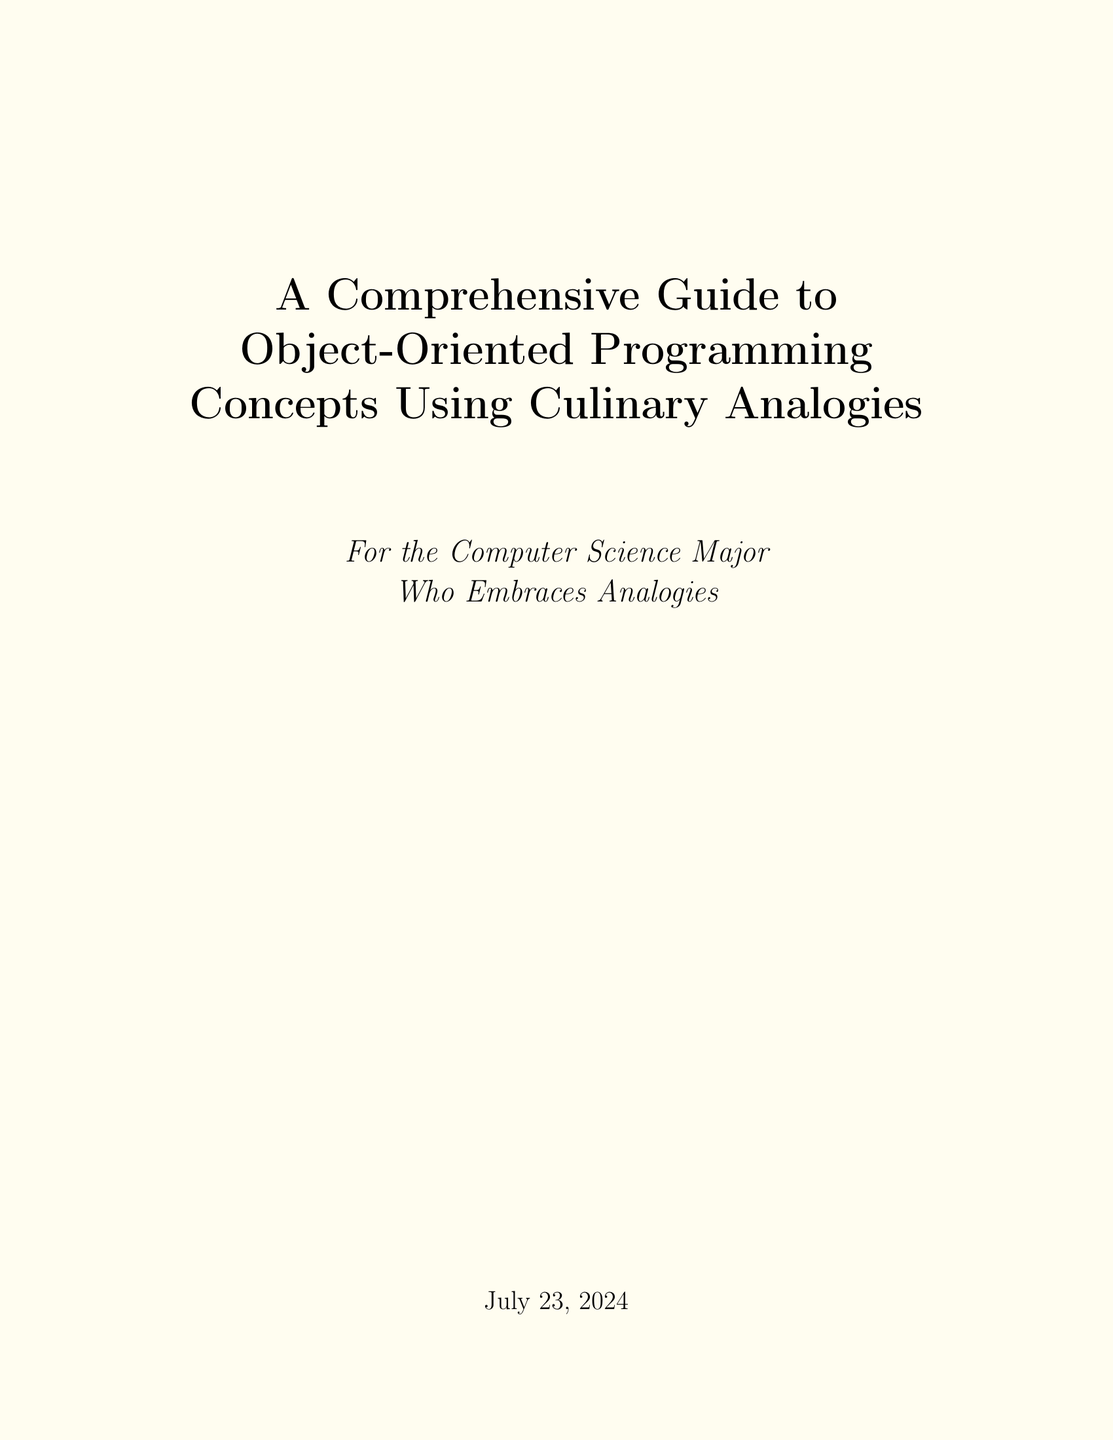What is the title of the document? The title is stated at the top of the document, presenting the main focus of the content.
Answer: A Comprehensive Guide to Object-Oriented Programming Concepts Using Culinary Analogies What analogy is used to explain classes in OOP? The document explains classes by comparing them to recipes, providing a relatable context for understanding.
Answer: Recipes What does an object represent in this guide's analogy? The analogy mentioned refers to a prepared dish as a representation of objects in OOP.
Answer: Prepared dishes Which section discusses encapsulation? The title of the section covering encapsulation indicates its main focus on kitchen organization and access modifiers.
Answer: Organizing the Kitchen How are polymorphism and cooking explained? The explanation for polymorphism compares it to versatile cooking techniques, emphasizing adaptability in both fields.
Answer: Versatile cooking techniques What is the example provided for an abstract class? The document includes a specific example illustrating an abstract class related to pastries, showcasing the concept effectively.
Answer: abstract class Pastry Which OOP concept corresponds to kitchens having public and private areas? The explanation directly connects encapsulation with the organization of kitchen areas, using access modifiers as an analogy.
Answer: Encapsulation What is the conclusion's main takeaway? The conclusion summarizes the importance of relating culinary analogies to OOP concepts for better understanding.
Answer: Intuitive understanding 